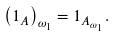<formula> <loc_0><loc_0><loc_500><loc_500>\left ( 1 _ { A } \right ) _ { \omega _ { 1 } } = 1 _ { A _ { \omega _ { 1 } } } .</formula> 